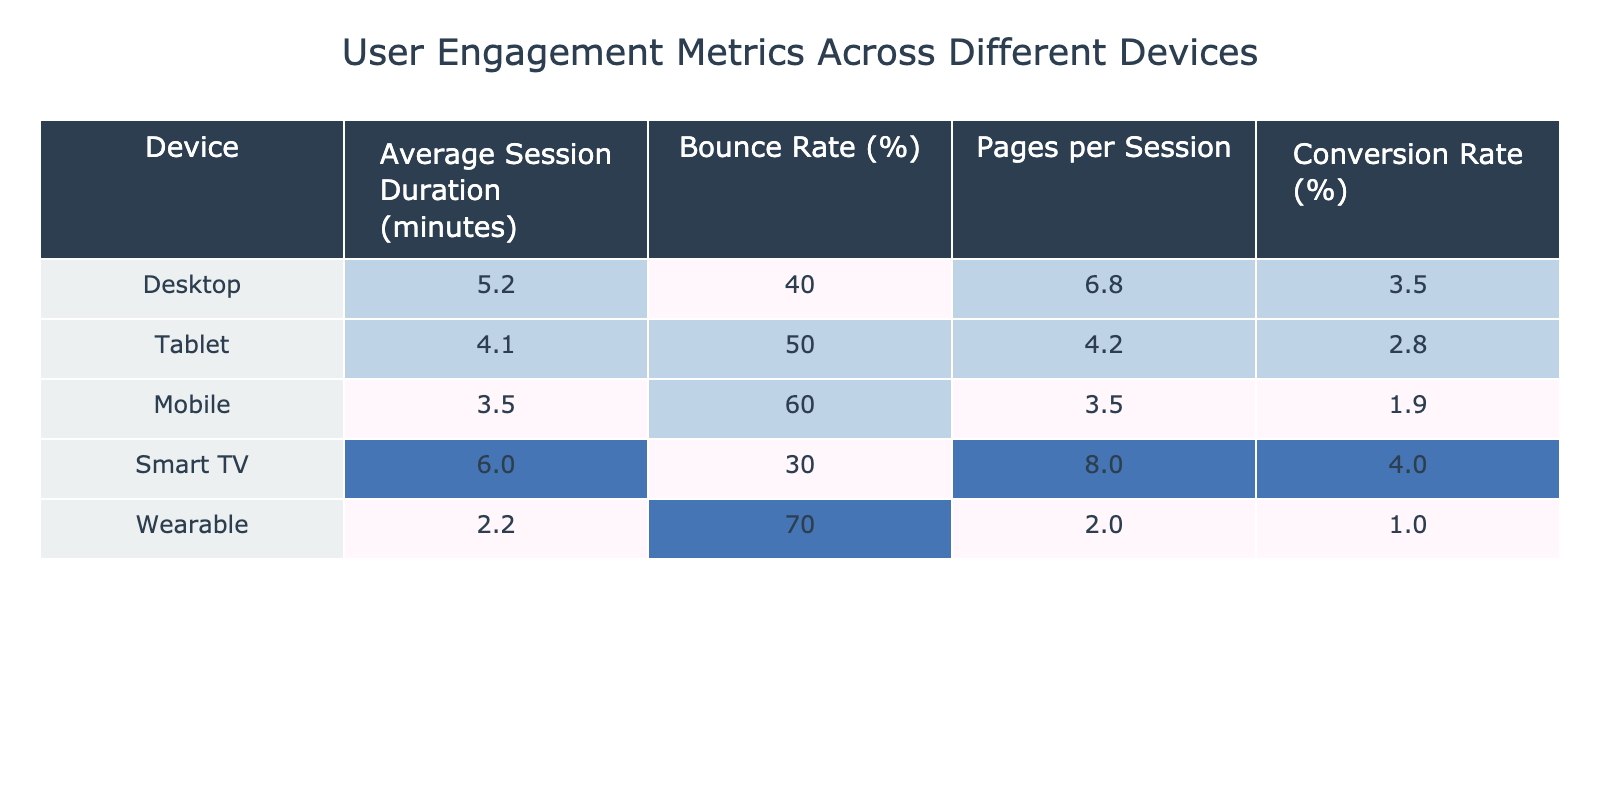What is the average session duration for Desktop users? The table shows that the average session duration for Desktop users is listed as 5.2 minutes.
Answer: 5.2 minutes Which device has the highest Bounce Rate? The Bounce Rate column indicates that the Wearable device has the highest Bounce Rate at 70%.
Answer: Wearable What is the Conversion Rate for Smart TV users? The table lists the Conversion Rate for Smart TV users as 4.0%.
Answer: 4.0% Calculate the total Pages per Session for all devices combined. Summing the Pages per Session values: 6.8 (Desktop) + 4.2 (Tablet) + 3.5 (Mobile) + 8.0 (Smart TV) + 2.0 (Wearable) = 24.5.
Answer: 24.5 Is the Average Session Duration for Mobile users more than that for Tablet users? The Average Session Duration for Mobile is 3.5 minutes and for Tablet is 4.1 minutes. Since 3.5 is less than 4.1, the statement is false.
Answer: No What is the difference in Bounce Rate between Smart TV and Mobile users? The Bounce Rate for Smart TV is 30% and for Mobile is 60%. The difference is 60% - 30% = 30%.
Answer: 30% Which device has the lowest Conversion Rate? The table shows that the Mobile device has the lowest Conversion Rate at 1.9%.
Answer: Mobile If we calculate the average Conversion Rate across all devices, what will it be? The Conversion Rates are 3.5 (Desktop) + 2.8 (Tablet) + 1.9 (Mobile) + 4.0 (Smart TV) + 1.0 (Wearable). Summing these gives 13.2, and dividing by 5 gives an average of 2.64%.
Answer: 2.64% Which device has the highest average session duration, and by how much does it exceed the next highest device? The Smart TV has the highest average session duration at 6.0 minutes. The next highest is Desktop at 5.2 minutes. The difference is 6.0 - 5.2 = 0.8 minutes.
Answer: Smart TV, 0.8 minutes Are there any devices with a Bounce Rate higher than 50%? The Bounce Rate for Tablet (50%) and Mobile (60%) both exceed 50%. Therefore, the answer is yes.
Answer: Yes 